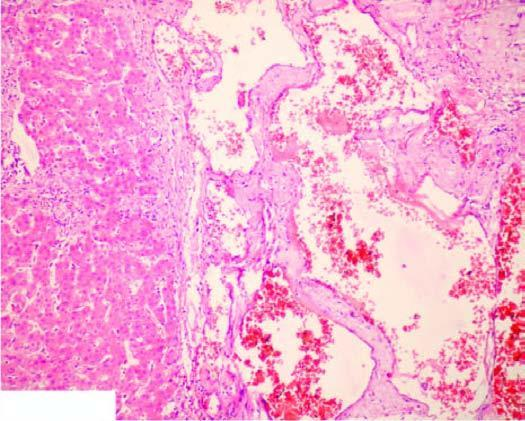re the vascular spaces large, dilated, many containing blood, and are lined by flattened endothelial cells?
Answer the question using a single word or phrase. Yes 